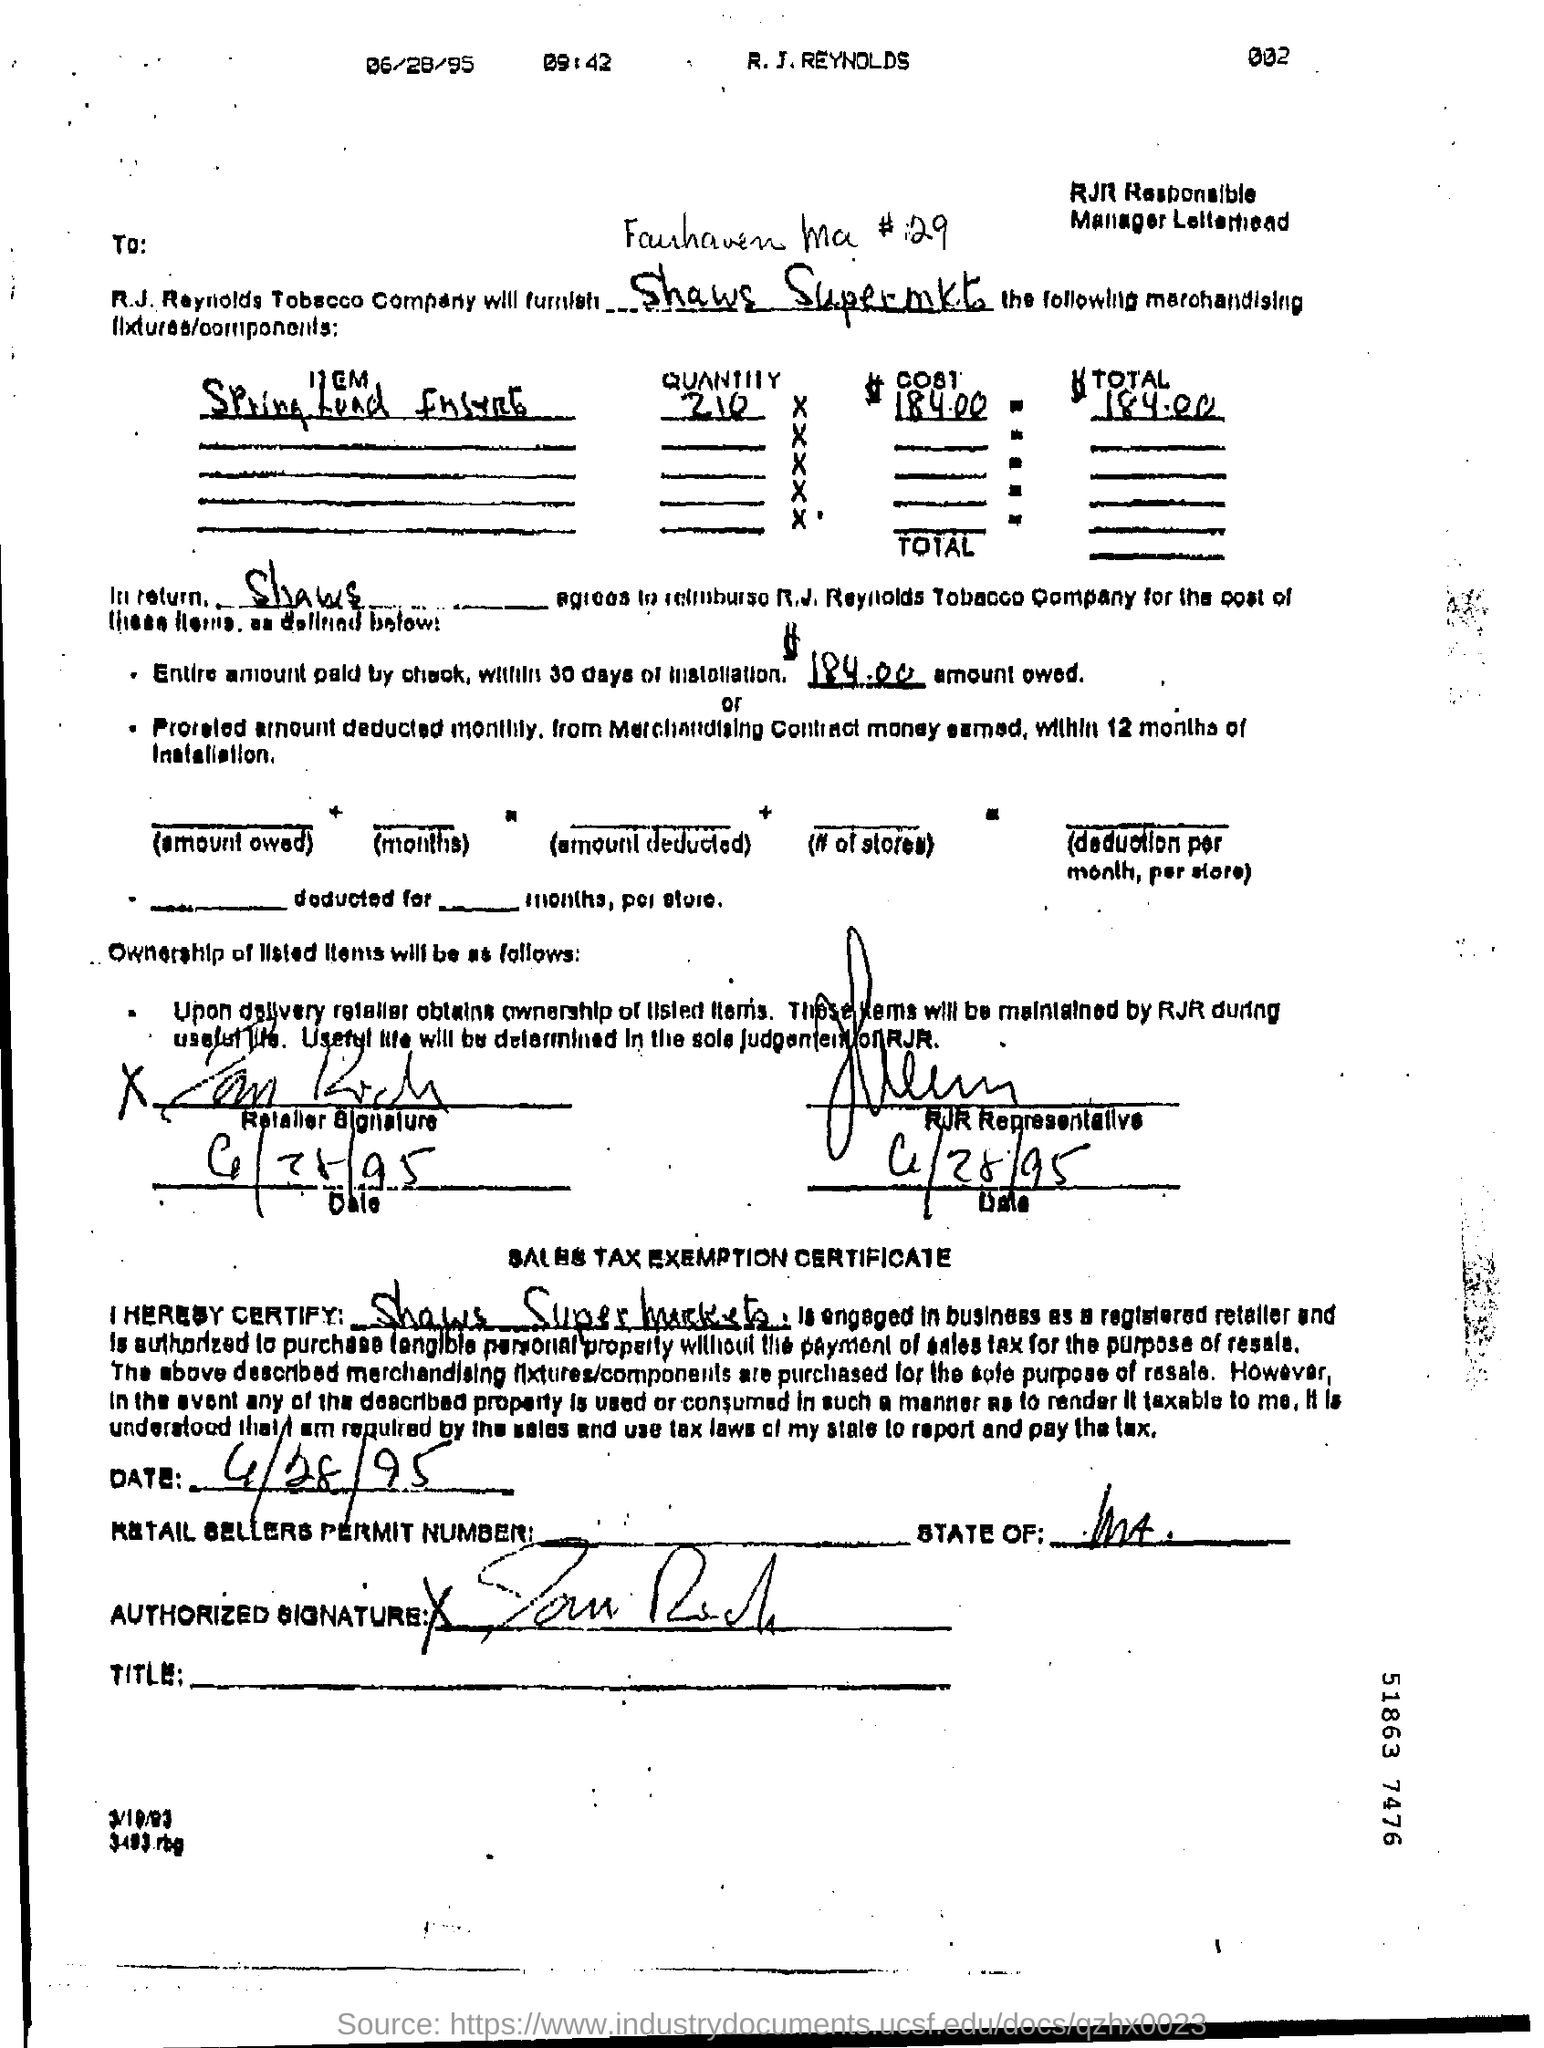How much is the entire amount paid by check within 30 days of installation ?
Offer a very short reply. $184.00. 